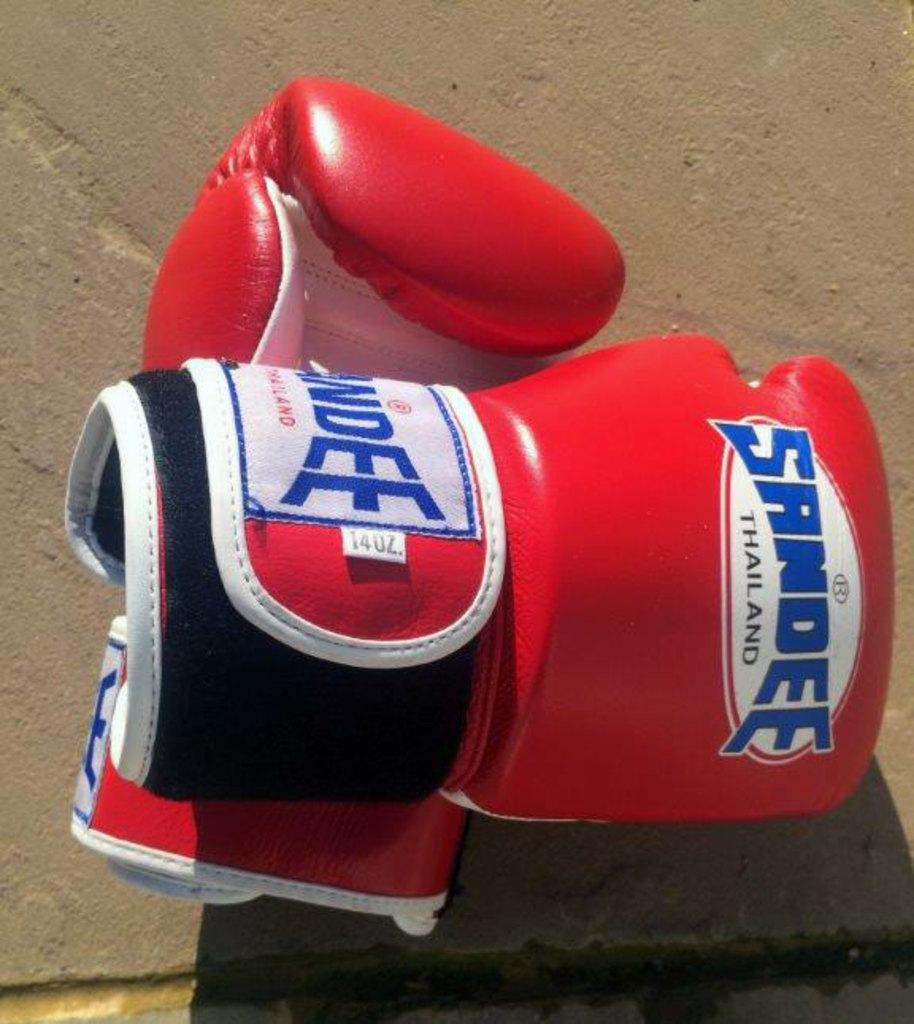<image>
Write a terse but informative summary of the picture. A pair of boxing gloves from Sandee Thailand sit on a concrete floor. 